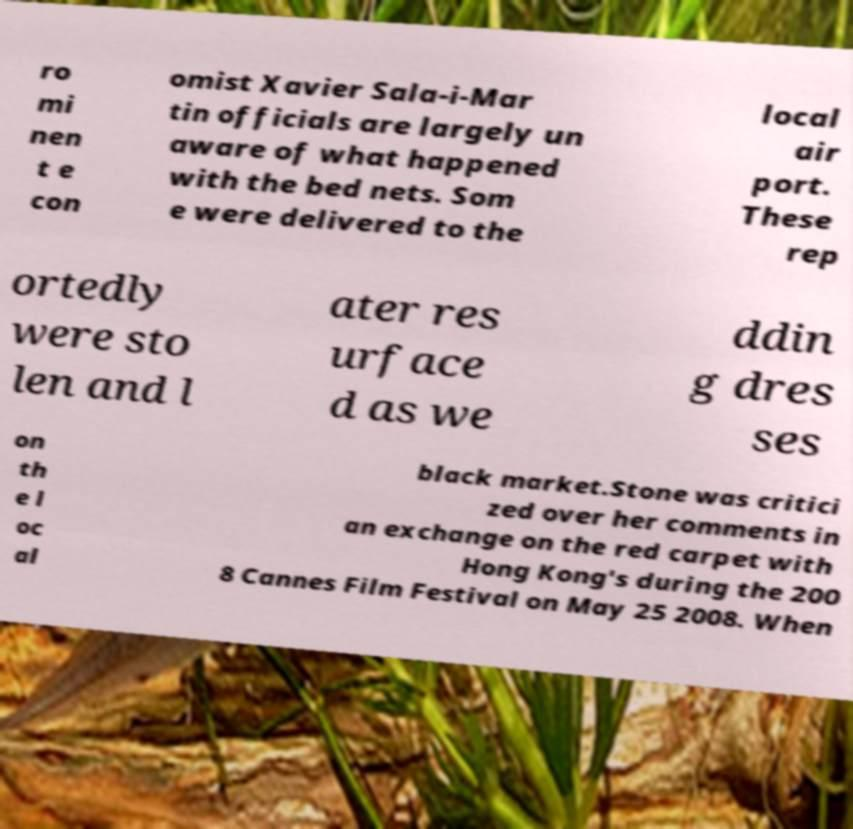For documentation purposes, I need the text within this image transcribed. Could you provide that? ro mi nen t e con omist Xavier Sala-i-Mar tin officials are largely un aware of what happened with the bed nets. Som e were delivered to the local air port. These rep ortedly were sto len and l ater res urface d as we ddin g dres ses on th e l oc al black market.Stone was critici zed over her comments in an exchange on the red carpet with Hong Kong's during the 200 8 Cannes Film Festival on May 25 2008. When 